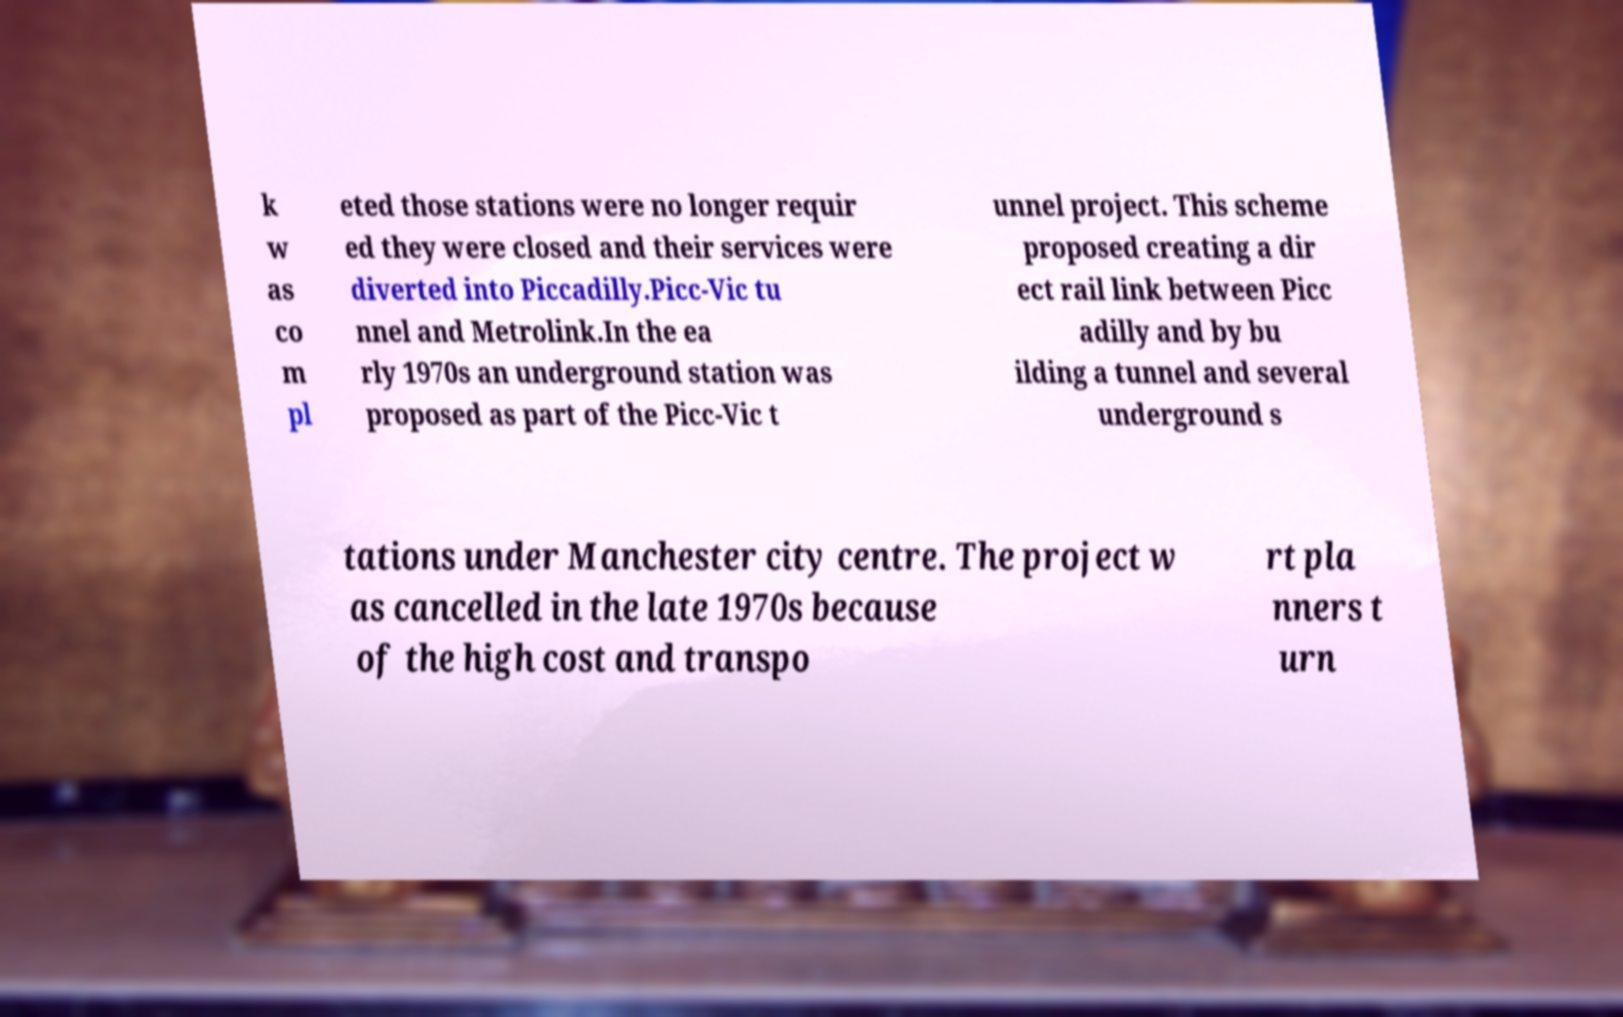Please read and relay the text visible in this image. What does it say? k w as co m pl eted those stations were no longer requir ed they were closed and their services were diverted into Piccadilly.Picc-Vic tu nnel and Metrolink.In the ea rly 1970s an underground station was proposed as part of the Picc-Vic t unnel project. This scheme proposed creating a dir ect rail link between Picc adilly and by bu ilding a tunnel and several underground s tations under Manchester city centre. The project w as cancelled in the late 1970s because of the high cost and transpo rt pla nners t urn 